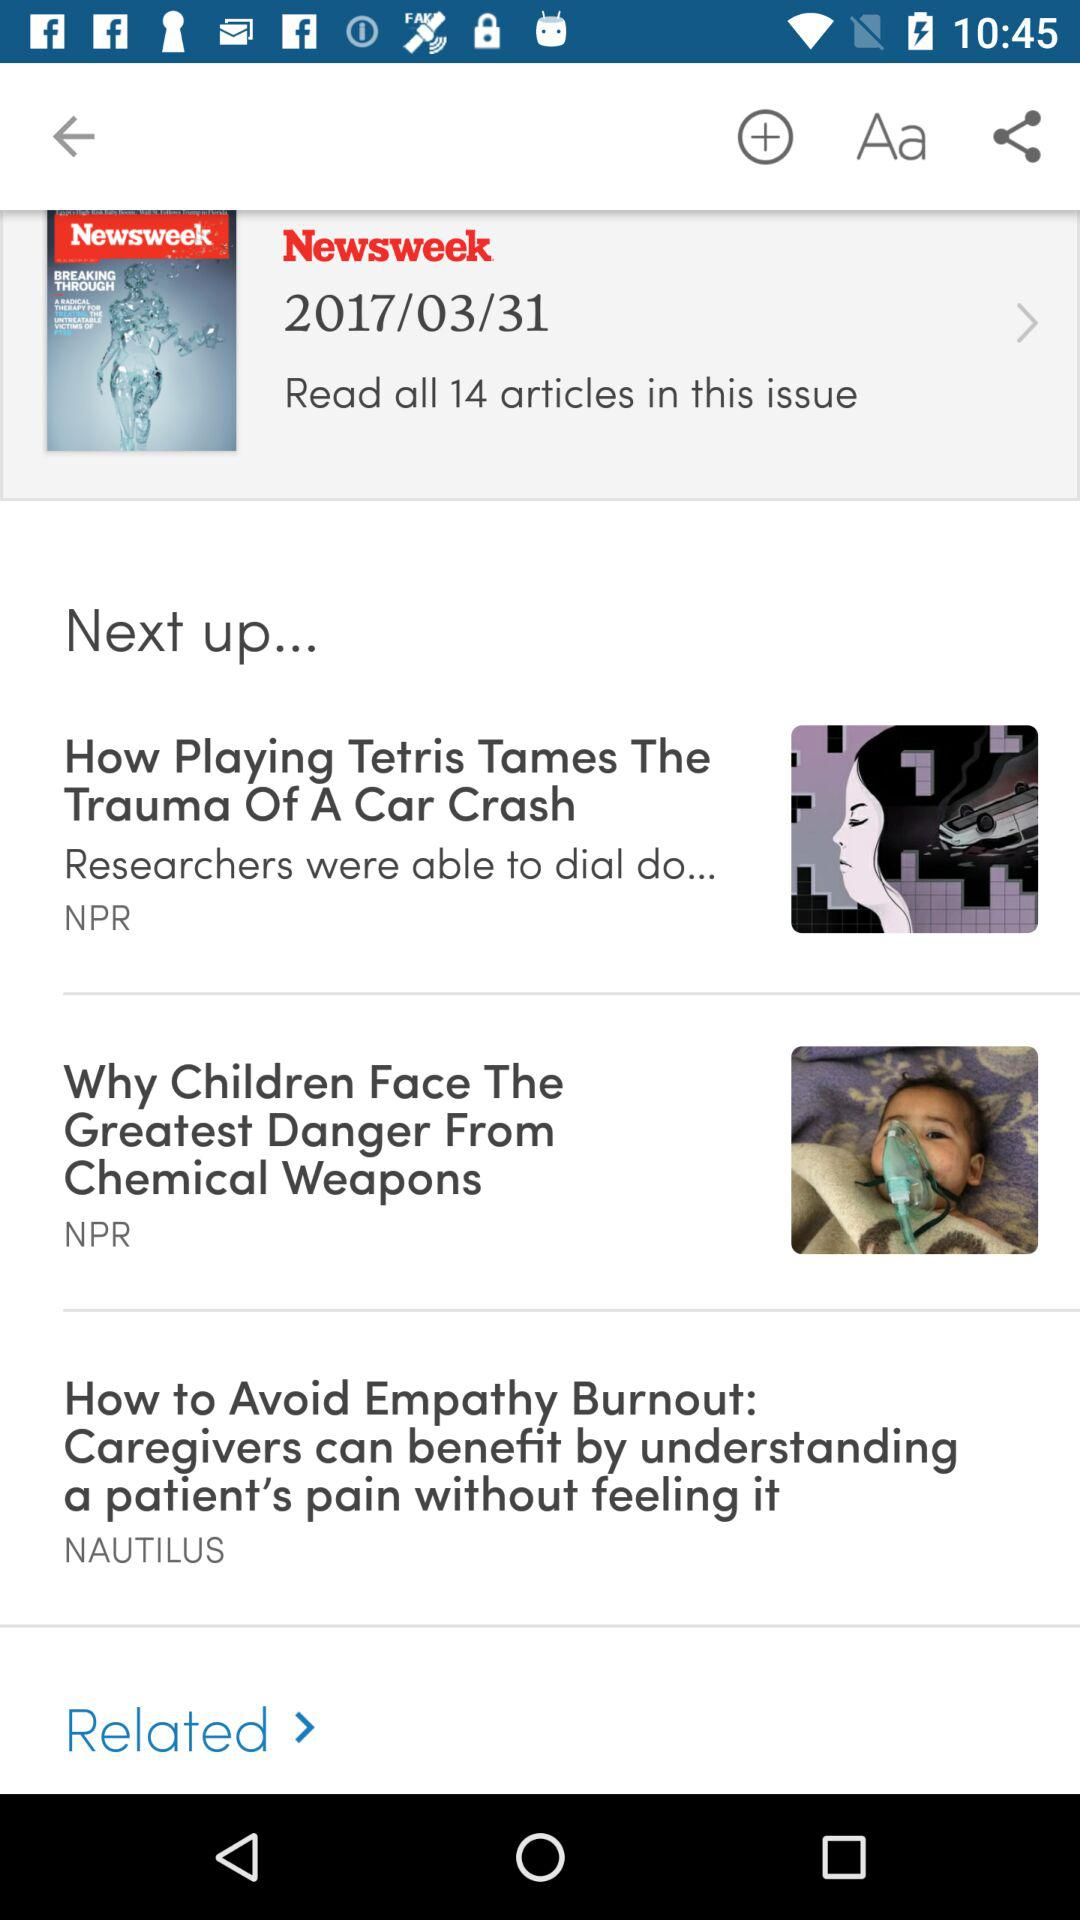How many articles are there in this issue?
Answer the question using a single word or phrase. 14 